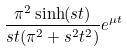Convert formula to latex. <formula><loc_0><loc_0><loc_500><loc_500>\frac { \pi ^ { 2 } \sinh ( s t ) } { s t ( \pi ^ { 2 } + s ^ { 2 } t ^ { 2 } ) } e ^ { \mu t }</formula> 